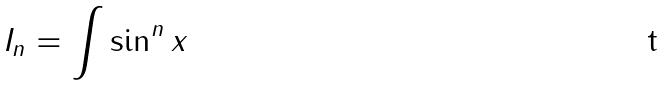Convert formula to latex. <formula><loc_0><loc_0><loc_500><loc_500>I _ { n } = \int \sin ^ { n } x</formula> 